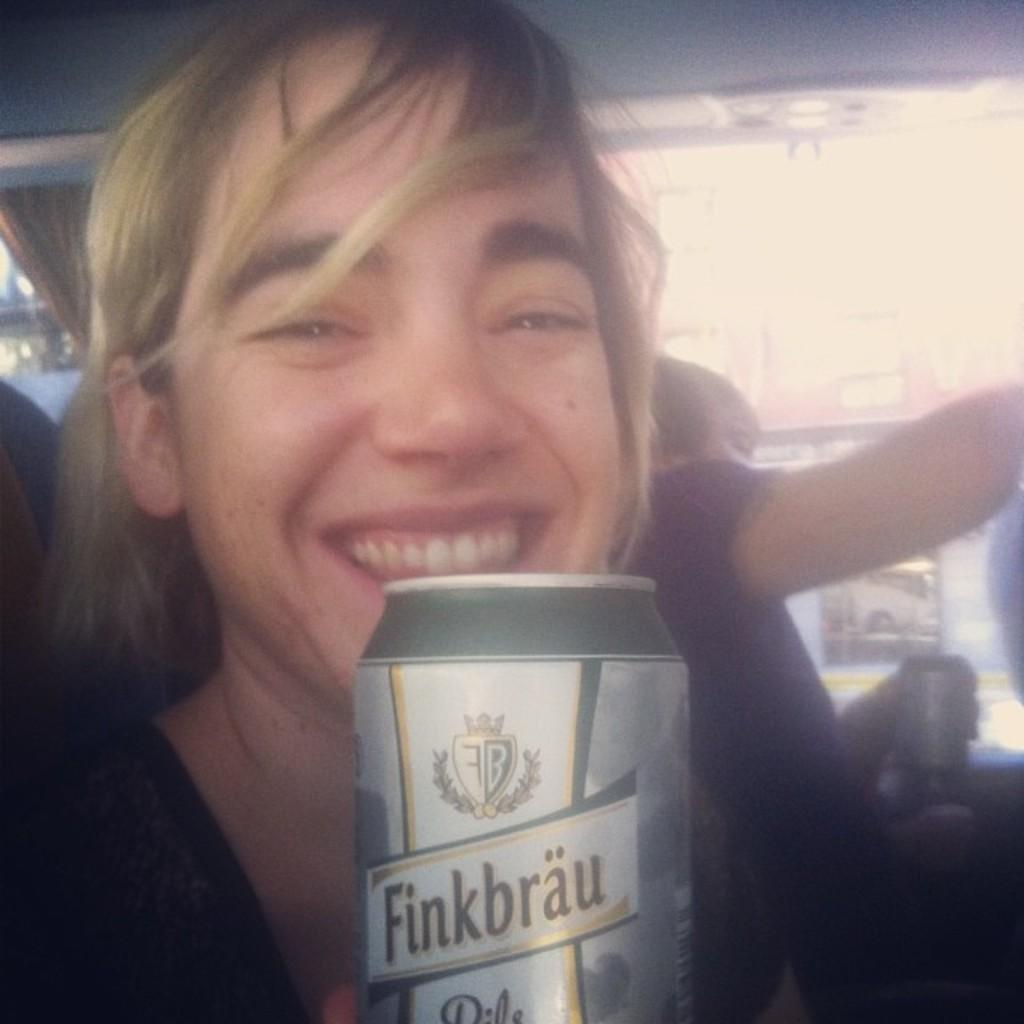Could you give a brief overview of what you see in this image? In this image I can see a person smiling and holding tin. Back I can see person sitting. 